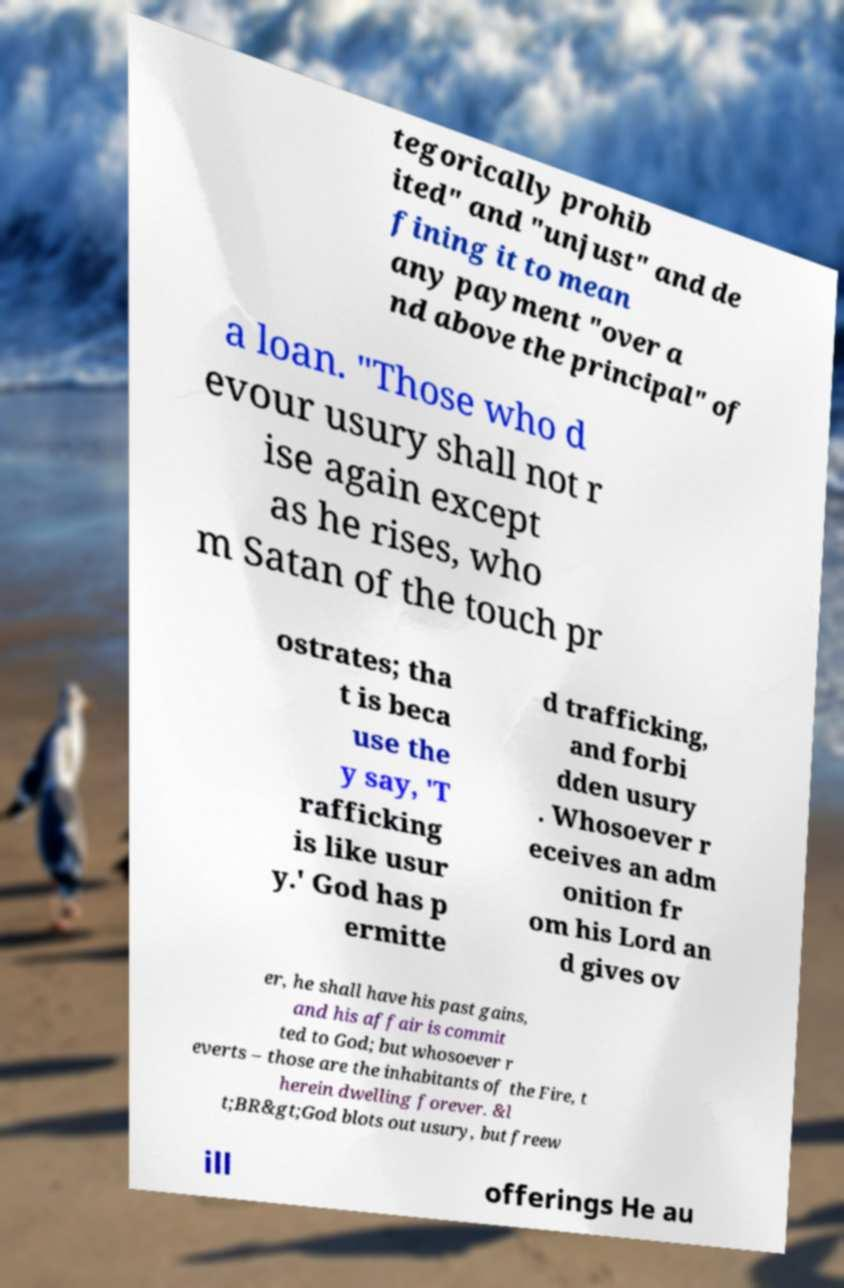Can you read and provide the text displayed in the image?This photo seems to have some interesting text. Can you extract and type it out for me? tegorically prohib ited" and "unjust" and de fining it to mean any payment "over a nd above the principal" of a loan. "Those who d evour usury shall not r ise again except as he rises, who m Satan of the touch pr ostrates; tha t is beca use the y say, 'T rafficking is like usur y.' God has p ermitte d trafficking, and forbi dden usury . Whosoever r eceives an adm onition fr om his Lord an d gives ov er, he shall have his past gains, and his affair is commit ted to God; but whosoever r everts – those are the inhabitants of the Fire, t herein dwelling forever. &l t;BR&gt;God blots out usury, but freew ill offerings He au 